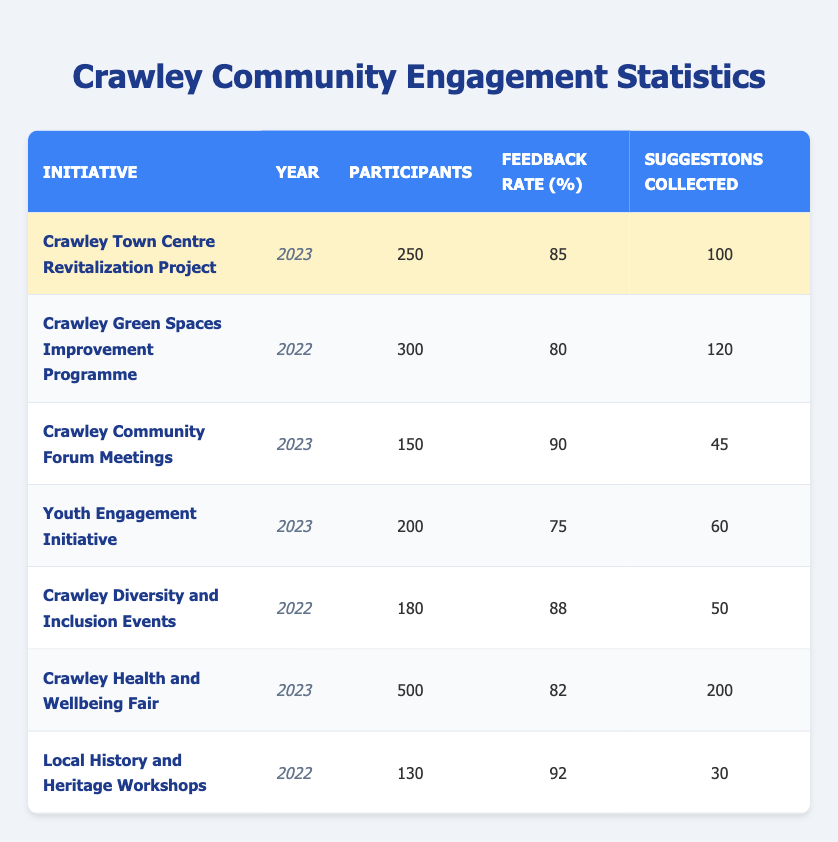What is the feedback rate for the Crawley Town Centre Revitalization Project? The table indicates that the feedback rate for this initiative is listed under the "Feedback Rate (%)" column for the year 2023, which shows 85%.
Answer: 85% How many participants were involved in the Crawley Health and Wellbeing Fair? Referring to the initiative "Crawley Health and Wellbeing Fair" in the table, the number of participants is specified as 500.
Answer: 500 Which initiative had the highest number of participants in 2022? By reviewing the participants for all initiatives from the year 2022, the "Crawley Green Spaces Improvement Programme" had 300 participants, which is higher than all other initiatives in that year.
Answer: Crawley Green Spaces Improvement Programme What is the average feedback rate for all initiatives conducted in 2023? To find the average feedback rate for 2023, we take the feedback rates from the relevant initiatives: (85 + 90 + 75 + 82) = 332, and then divide by the number of initiatives (4), giving 332 / 4 = 83%.
Answer: 83% Did more than 80 participants provide suggestions for the Crawley Community Forum Meetings? The suggestions collected for the Crawley Community Forum Meetings is 45, which is less than 80, confirming that not more than 80 suggestions were received.
Answer: No Which initiative collected the most suggestions in 2023? Looking at the table for the year 2023, the "Crawley Health and Wellbeing Fair" collected 200 suggestions, which is the highest number compared to other initiatives in that year.
Answer: Crawley Health and Wellbeing Fair What is the difference in the number of participants between the Crawley Green Spaces Improvement Programme and the Local History and Heritage Workshops? The Crawley Green Spaces Improvement Programme has 300 participants and the Local History and Heritage Workshops has 130 participants. The difference is 300 - 130 = 170 participants.
Answer: 170 How many total suggestions were collected from all initiatives in 2022? To find the total suggestions for 2022, we add the suggestions collected from each relevant initiative: 120 (Crawley Green Spaces) + 50 (Diversity and Inclusion) + 30 (Local History) = 200.
Answer: 200 Was the feedback rate for Youth Engagement Initiative lower than 80%? The feedback rate for the Youth Engagement Initiative is 75%, which is indeed lower than 80%.
Answer: Yes Which initiative had the lowest feedback rate in 2023? In 2023, the initiatives were assessed, and the Youth Engagement Initiative had the lowest feedback rate of 75% among the others listed.
Answer: Youth Engagement Initiative 